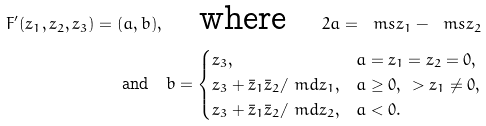Convert formula to latex. <formula><loc_0><loc_0><loc_500><loc_500>F ^ { \prime } ( z _ { 1 } , z _ { 2 } , z _ { 3 } ) = ( a , b ) , \quad \text {where} \quad 2 a = \ m s { z _ { 1 } } - \ m s { z _ { 2 } } \\ \text {and} \quad b = \begin{cases} z _ { 3 } , & a = z _ { 1 } = z _ { 2 } = 0 , \\ z _ { 3 } + \bar { z } _ { 1 } \bar { z } _ { 2 } / \ m d { z _ { 1 } } , & a \geq 0 , \, \ > z _ { 1 } \ne 0 , \\ z _ { 3 } + \bar { z } _ { 1 } \bar { z } _ { 2 } / \ m d { z _ { 2 } } , & a < 0 . \end{cases}</formula> 